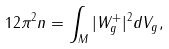Convert formula to latex. <formula><loc_0><loc_0><loc_500><loc_500>1 2 \pi ^ { 2 } n = \int _ { M } | W ^ { + } _ { g } | ^ { 2 } d V _ { g } ,</formula> 